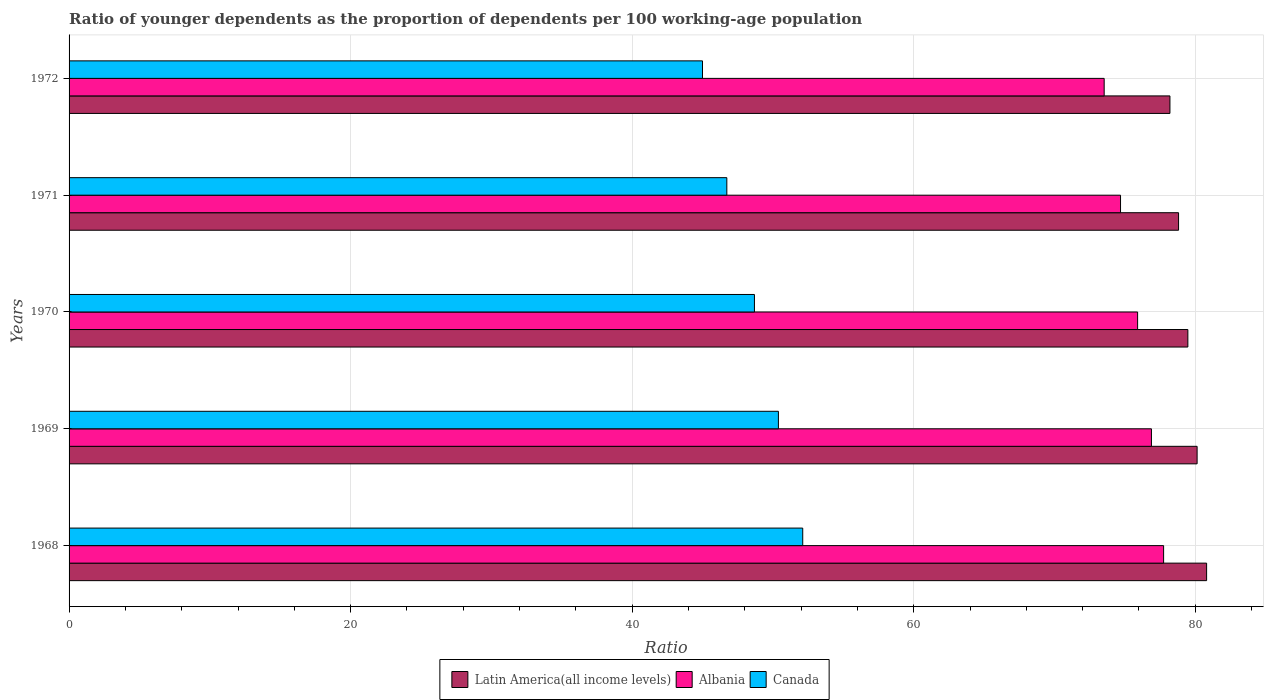How many groups of bars are there?
Provide a short and direct response. 5. Are the number of bars per tick equal to the number of legend labels?
Provide a succinct answer. Yes. What is the label of the 1st group of bars from the top?
Provide a short and direct response. 1972. In how many cases, is the number of bars for a given year not equal to the number of legend labels?
Your response must be concise. 0. What is the age dependency ratio(young) in Canada in 1969?
Give a very brief answer. 50.39. Across all years, what is the maximum age dependency ratio(young) in Latin America(all income levels)?
Ensure brevity in your answer.  80.81. Across all years, what is the minimum age dependency ratio(young) in Albania?
Your answer should be very brief. 73.53. In which year was the age dependency ratio(young) in Canada maximum?
Provide a short and direct response. 1968. In which year was the age dependency ratio(young) in Canada minimum?
Offer a very short reply. 1972. What is the total age dependency ratio(young) in Latin America(all income levels) in the graph?
Provide a succinct answer. 397.43. What is the difference between the age dependency ratio(young) in Latin America(all income levels) in 1971 and that in 1972?
Your answer should be compact. 0.61. What is the difference between the age dependency ratio(young) in Latin America(all income levels) in 1969 and the age dependency ratio(young) in Albania in 1972?
Keep it short and to the point. 6.6. What is the average age dependency ratio(young) in Albania per year?
Your response must be concise. 75.75. In the year 1972, what is the difference between the age dependency ratio(young) in Canada and age dependency ratio(young) in Albania?
Keep it short and to the point. -28.53. What is the ratio of the age dependency ratio(young) in Albania in 1968 to that in 1970?
Ensure brevity in your answer.  1.02. Is the age dependency ratio(young) in Latin America(all income levels) in 1970 less than that in 1971?
Your answer should be compact. No. Is the difference between the age dependency ratio(young) in Canada in 1969 and 1970 greater than the difference between the age dependency ratio(young) in Albania in 1969 and 1970?
Your answer should be compact. Yes. What is the difference between the highest and the second highest age dependency ratio(young) in Latin America(all income levels)?
Offer a very short reply. 0.67. What is the difference between the highest and the lowest age dependency ratio(young) in Canada?
Provide a succinct answer. 7.12. Is the sum of the age dependency ratio(young) in Canada in 1969 and 1971 greater than the maximum age dependency ratio(young) in Latin America(all income levels) across all years?
Your answer should be compact. Yes. What does the 3rd bar from the bottom in 1968 represents?
Keep it short and to the point. Canada. How many years are there in the graph?
Ensure brevity in your answer.  5. What is the difference between two consecutive major ticks on the X-axis?
Offer a terse response. 20. Are the values on the major ticks of X-axis written in scientific E-notation?
Your answer should be very brief. No. Does the graph contain any zero values?
Ensure brevity in your answer.  No. Does the graph contain grids?
Your response must be concise. Yes. Where does the legend appear in the graph?
Offer a terse response. Bottom center. How many legend labels are there?
Offer a very short reply. 3. How are the legend labels stacked?
Provide a succinct answer. Horizontal. What is the title of the graph?
Your response must be concise. Ratio of younger dependents as the proportion of dependents per 100 working-age population. What is the label or title of the X-axis?
Give a very brief answer. Ratio. What is the Ratio of Latin America(all income levels) in 1968?
Keep it short and to the point. 80.81. What is the Ratio of Albania in 1968?
Provide a short and direct response. 77.75. What is the Ratio in Canada in 1968?
Your response must be concise. 52.12. What is the Ratio of Latin America(all income levels) in 1969?
Make the answer very short. 80.13. What is the Ratio in Albania in 1969?
Provide a succinct answer. 76.89. What is the Ratio of Canada in 1969?
Provide a succinct answer. 50.39. What is the Ratio in Latin America(all income levels) in 1970?
Provide a succinct answer. 79.47. What is the Ratio in Albania in 1970?
Your response must be concise. 75.9. What is the Ratio of Canada in 1970?
Give a very brief answer. 48.69. What is the Ratio of Latin America(all income levels) in 1971?
Ensure brevity in your answer.  78.81. What is the Ratio in Albania in 1971?
Provide a succinct answer. 74.69. What is the Ratio of Canada in 1971?
Provide a short and direct response. 46.72. What is the Ratio of Latin America(all income levels) in 1972?
Offer a terse response. 78.2. What is the Ratio of Albania in 1972?
Provide a short and direct response. 73.53. What is the Ratio in Canada in 1972?
Provide a short and direct response. 45. Across all years, what is the maximum Ratio of Latin America(all income levels)?
Your answer should be very brief. 80.81. Across all years, what is the maximum Ratio in Albania?
Give a very brief answer. 77.75. Across all years, what is the maximum Ratio in Canada?
Keep it short and to the point. 52.12. Across all years, what is the minimum Ratio of Latin America(all income levels)?
Provide a short and direct response. 78.2. Across all years, what is the minimum Ratio of Albania?
Ensure brevity in your answer.  73.53. Across all years, what is the minimum Ratio of Canada?
Ensure brevity in your answer.  45. What is the total Ratio in Latin America(all income levels) in the graph?
Your answer should be very brief. 397.43. What is the total Ratio of Albania in the graph?
Your answer should be very brief. 378.76. What is the total Ratio of Canada in the graph?
Ensure brevity in your answer.  242.91. What is the difference between the Ratio of Latin America(all income levels) in 1968 and that in 1969?
Offer a very short reply. 0.67. What is the difference between the Ratio of Albania in 1968 and that in 1969?
Offer a very short reply. 0.87. What is the difference between the Ratio of Canada in 1968 and that in 1969?
Ensure brevity in your answer.  1.73. What is the difference between the Ratio in Latin America(all income levels) in 1968 and that in 1970?
Your answer should be compact. 1.33. What is the difference between the Ratio of Albania in 1968 and that in 1970?
Your answer should be compact. 1.85. What is the difference between the Ratio of Canada in 1968 and that in 1970?
Keep it short and to the point. 3.43. What is the difference between the Ratio of Latin America(all income levels) in 1968 and that in 1971?
Make the answer very short. 1.99. What is the difference between the Ratio in Albania in 1968 and that in 1971?
Ensure brevity in your answer.  3.06. What is the difference between the Ratio of Canada in 1968 and that in 1971?
Your answer should be compact. 5.39. What is the difference between the Ratio in Latin America(all income levels) in 1968 and that in 1972?
Your answer should be very brief. 2.61. What is the difference between the Ratio of Albania in 1968 and that in 1972?
Make the answer very short. 4.22. What is the difference between the Ratio of Canada in 1968 and that in 1972?
Your answer should be compact. 7.12. What is the difference between the Ratio in Latin America(all income levels) in 1969 and that in 1970?
Keep it short and to the point. 0.66. What is the difference between the Ratio in Canada in 1969 and that in 1970?
Make the answer very short. 1.7. What is the difference between the Ratio of Latin America(all income levels) in 1969 and that in 1971?
Offer a very short reply. 1.32. What is the difference between the Ratio of Albania in 1969 and that in 1971?
Keep it short and to the point. 2.19. What is the difference between the Ratio in Canada in 1969 and that in 1971?
Provide a short and direct response. 3.66. What is the difference between the Ratio of Latin America(all income levels) in 1969 and that in 1972?
Provide a succinct answer. 1.93. What is the difference between the Ratio of Albania in 1969 and that in 1972?
Give a very brief answer. 3.36. What is the difference between the Ratio of Canada in 1969 and that in 1972?
Offer a terse response. 5.39. What is the difference between the Ratio in Latin America(all income levels) in 1970 and that in 1971?
Give a very brief answer. 0.66. What is the difference between the Ratio of Albania in 1970 and that in 1971?
Give a very brief answer. 1.21. What is the difference between the Ratio of Canada in 1970 and that in 1971?
Make the answer very short. 1.96. What is the difference between the Ratio of Latin America(all income levels) in 1970 and that in 1972?
Your response must be concise. 1.27. What is the difference between the Ratio in Albania in 1970 and that in 1972?
Keep it short and to the point. 2.38. What is the difference between the Ratio in Canada in 1970 and that in 1972?
Offer a very short reply. 3.69. What is the difference between the Ratio in Latin America(all income levels) in 1971 and that in 1972?
Make the answer very short. 0.61. What is the difference between the Ratio of Albania in 1971 and that in 1972?
Ensure brevity in your answer.  1.16. What is the difference between the Ratio in Canada in 1971 and that in 1972?
Offer a terse response. 1.73. What is the difference between the Ratio in Latin America(all income levels) in 1968 and the Ratio in Albania in 1969?
Offer a terse response. 3.92. What is the difference between the Ratio of Latin America(all income levels) in 1968 and the Ratio of Canada in 1969?
Provide a short and direct response. 30.42. What is the difference between the Ratio in Albania in 1968 and the Ratio in Canada in 1969?
Keep it short and to the point. 27.36. What is the difference between the Ratio of Latin America(all income levels) in 1968 and the Ratio of Albania in 1970?
Your answer should be compact. 4.9. What is the difference between the Ratio in Latin America(all income levels) in 1968 and the Ratio in Canada in 1970?
Make the answer very short. 32.12. What is the difference between the Ratio of Albania in 1968 and the Ratio of Canada in 1970?
Your answer should be compact. 29.07. What is the difference between the Ratio in Latin America(all income levels) in 1968 and the Ratio in Albania in 1971?
Keep it short and to the point. 6.11. What is the difference between the Ratio of Latin America(all income levels) in 1968 and the Ratio of Canada in 1971?
Your response must be concise. 34.08. What is the difference between the Ratio in Albania in 1968 and the Ratio in Canada in 1971?
Keep it short and to the point. 31.03. What is the difference between the Ratio of Latin America(all income levels) in 1968 and the Ratio of Albania in 1972?
Your response must be concise. 7.28. What is the difference between the Ratio in Latin America(all income levels) in 1968 and the Ratio in Canada in 1972?
Give a very brief answer. 35.81. What is the difference between the Ratio in Albania in 1968 and the Ratio in Canada in 1972?
Give a very brief answer. 32.76. What is the difference between the Ratio of Latin America(all income levels) in 1969 and the Ratio of Albania in 1970?
Ensure brevity in your answer.  4.23. What is the difference between the Ratio of Latin America(all income levels) in 1969 and the Ratio of Canada in 1970?
Offer a very short reply. 31.45. What is the difference between the Ratio in Albania in 1969 and the Ratio in Canada in 1970?
Provide a short and direct response. 28.2. What is the difference between the Ratio of Latin America(all income levels) in 1969 and the Ratio of Albania in 1971?
Your response must be concise. 5.44. What is the difference between the Ratio in Latin America(all income levels) in 1969 and the Ratio in Canada in 1971?
Make the answer very short. 33.41. What is the difference between the Ratio of Albania in 1969 and the Ratio of Canada in 1971?
Offer a terse response. 30.16. What is the difference between the Ratio of Latin America(all income levels) in 1969 and the Ratio of Albania in 1972?
Give a very brief answer. 6.6. What is the difference between the Ratio of Latin America(all income levels) in 1969 and the Ratio of Canada in 1972?
Provide a short and direct response. 35.14. What is the difference between the Ratio of Albania in 1969 and the Ratio of Canada in 1972?
Offer a very short reply. 31.89. What is the difference between the Ratio in Latin America(all income levels) in 1970 and the Ratio in Albania in 1971?
Ensure brevity in your answer.  4.78. What is the difference between the Ratio of Latin America(all income levels) in 1970 and the Ratio of Canada in 1971?
Your answer should be compact. 32.75. What is the difference between the Ratio of Albania in 1970 and the Ratio of Canada in 1971?
Provide a succinct answer. 29.18. What is the difference between the Ratio of Latin America(all income levels) in 1970 and the Ratio of Albania in 1972?
Make the answer very short. 5.94. What is the difference between the Ratio in Latin America(all income levels) in 1970 and the Ratio in Canada in 1972?
Make the answer very short. 34.48. What is the difference between the Ratio of Albania in 1970 and the Ratio of Canada in 1972?
Your answer should be very brief. 30.91. What is the difference between the Ratio of Latin America(all income levels) in 1971 and the Ratio of Albania in 1972?
Give a very brief answer. 5.28. What is the difference between the Ratio in Latin America(all income levels) in 1971 and the Ratio in Canada in 1972?
Provide a short and direct response. 33.82. What is the difference between the Ratio in Albania in 1971 and the Ratio in Canada in 1972?
Your answer should be compact. 29.7. What is the average Ratio in Latin America(all income levels) per year?
Make the answer very short. 79.49. What is the average Ratio in Albania per year?
Offer a terse response. 75.75. What is the average Ratio of Canada per year?
Offer a terse response. 48.58. In the year 1968, what is the difference between the Ratio of Latin America(all income levels) and Ratio of Albania?
Your answer should be very brief. 3.05. In the year 1968, what is the difference between the Ratio of Latin America(all income levels) and Ratio of Canada?
Your answer should be compact. 28.69. In the year 1968, what is the difference between the Ratio of Albania and Ratio of Canada?
Provide a succinct answer. 25.64. In the year 1969, what is the difference between the Ratio of Latin America(all income levels) and Ratio of Albania?
Your response must be concise. 3.25. In the year 1969, what is the difference between the Ratio of Latin America(all income levels) and Ratio of Canada?
Your answer should be very brief. 29.74. In the year 1969, what is the difference between the Ratio of Albania and Ratio of Canada?
Offer a very short reply. 26.5. In the year 1970, what is the difference between the Ratio in Latin America(all income levels) and Ratio in Albania?
Give a very brief answer. 3.57. In the year 1970, what is the difference between the Ratio of Latin America(all income levels) and Ratio of Canada?
Your response must be concise. 30.79. In the year 1970, what is the difference between the Ratio in Albania and Ratio in Canada?
Ensure brevity in your answer.  27.22. In the year 1971, what is the difference between the Ratio of Latin America(all income levels) and Ratio of Albania?
Give a very brief answer. 4.12. In the year 1971, what is the difference between the Ratio of Latin America(all income levels) and Ratio of Canada?
Offer a very short reply. 32.09. In the year 1971, what is the difference between the Ratio in Albania and Ratio in Canada?
Give a very brief answer. 27.97. In the year 1972, what is the difference between the Ratio of Latin America(all income levels) and Ratio of Albania?
Keep it short and to the point. 4.67. In the year 1972, what is the difference between the Ratio of Latin America(all income levels) and Ratio of Canada?
Your response must be concise. 33.2. In the year 1972, what is the difference between the Ratio of Albania and Ratio of Canada?
Keep it short and to the point. 28.53. What is the ratio of the Ratio in Latin America(all income levels) in 1968 to that in 1969?
Your answer should be compact. 1.01. What is the ratio of the Ratio in Albania in 1968 to that in 1969?
Ensure brevity in your answer.  1.01. What is the ratio of the Ratio in Canada in 1968 to that in 1969?
Ensure brevity in your answer.  1.03. What is the ratio of the Ratio of Latin America(all income levels) in 1968 to that in 1970?
Your response must be concise. 1.02. What is the ratio of the Ratio of Albania in 1968 to that in 1970?
Keep it short and to the point. 1.02. What is the ratio of the Ratio in Canada in 1968 to that in 1970?
Provide a short and direct response. 1.07. What is the ratio of the Ratio in Latin America(all income levels) in 1968 to that in 1971?
Offer a terse response. 1.03. What is the ratio of the Ratio of Albania in 1968 to that in 1971?
Give a very brief answer. 1.04. What is the ratio of the Ratio of Canada in 1968 to that in 1971?
Make the answer very short. 1.12. What is the ratio of the Ratio of Latin America(all income levels) in 1968 to that in 1972?
Keep it short and to the point. 1.03. What is the ratio of the Ratio in Albania in 1968 to that in 1972?
Your response must be concise. 1.06. What is the ratio of the Ratio of Canada in 1968 to that in 1972?
Provide a short and direct response. 1.16. What is the ratio of the Ratio in Latin America(all income levels) in 1969 to that in 1970?
Give a very brief answer. 1.01. What is the ratio of the Ratio in Albania in 1969 to that in 1970?
Give a very brief answer. 1.01. What is the ratio of the Ratio of Canada in 1969 to that in 1970?
Provide a short and direct response. 1.03. What is the ratio of the Ratio in Latin America(all income levels) in 1969 to that in 1971?
Offer a very short reply. 1.02. What is the ratio of the Ratio in Albania in 1969 to that in 1971?
Provide a short and direct response. 1.03. What is the ratio of the Ratio of Canada in 1969 to that in 1971?
Your answer should be very brief. 1.08. What is the ratio of the Ratio in Latin America(all income levels) in 1969 to that in 1972?
Your answer should be compact. 1.02. What is the ratio of the Ratio of Albania in 1969 to that in 1972?
Offer a very short reply. 1.05. What is the ratio of the Ratio of Canada in 1969 to that in 1972?
Make the answer very short. 1.12. What is the ratio of the Ratio of Latin America(all income levels) in 1970 to that in 1971?
Make the answer very short. 1.01. What is the ratio of the Ratio in Albania in 1970 to that in 1971?
Your answer should be very brief. 1.02. What is the ratio of the Ratio in Canada in 1970 to that in 1971?
Offer a very short reply. 1.04. What is the ratio of the Ratio of Latin America(all income levels) in 1970 to that in 1972?
Provide a short and direct response. 1.02. What is the ratio of the Ratio of Albania in 1970 to that in 1972?
Your answer should be very brief. 1.03. What is the ratio of the Ratio in Canada in 1970 to that in 1972?
Offer a very short reply. 1.08. What is the ratio of the Ratio in Albania in 1971 to that in 1972?
Provide a succinct answer. 1.02. What is the ratio of the Ratio in Canada in 1971 to that in 1972?
Your response must be concise. 1.04. What is the difference between the highest and the second highest Ratio of Latin America(all income levels)?
Ensure brevity in your answer.  0.67. What is the difference between the highest and the second highest Ratio in Albania?
Your answer should be very brief. 0.87. What is the difference between the highest and the second highest Ratio in Canada?
Your answer should be compact. 1.73. What is the difference between the highest and the lowest Ratio of Latin America(all income levels)?
Make the answer very short. 2.61. What is the difference between the highest and the lowest Ratio of Albania?
Your response must be concise. 4.22. What is the difference between the highest and the lowest Ratio in Canada?
Give a very brief answer. 7.12. 